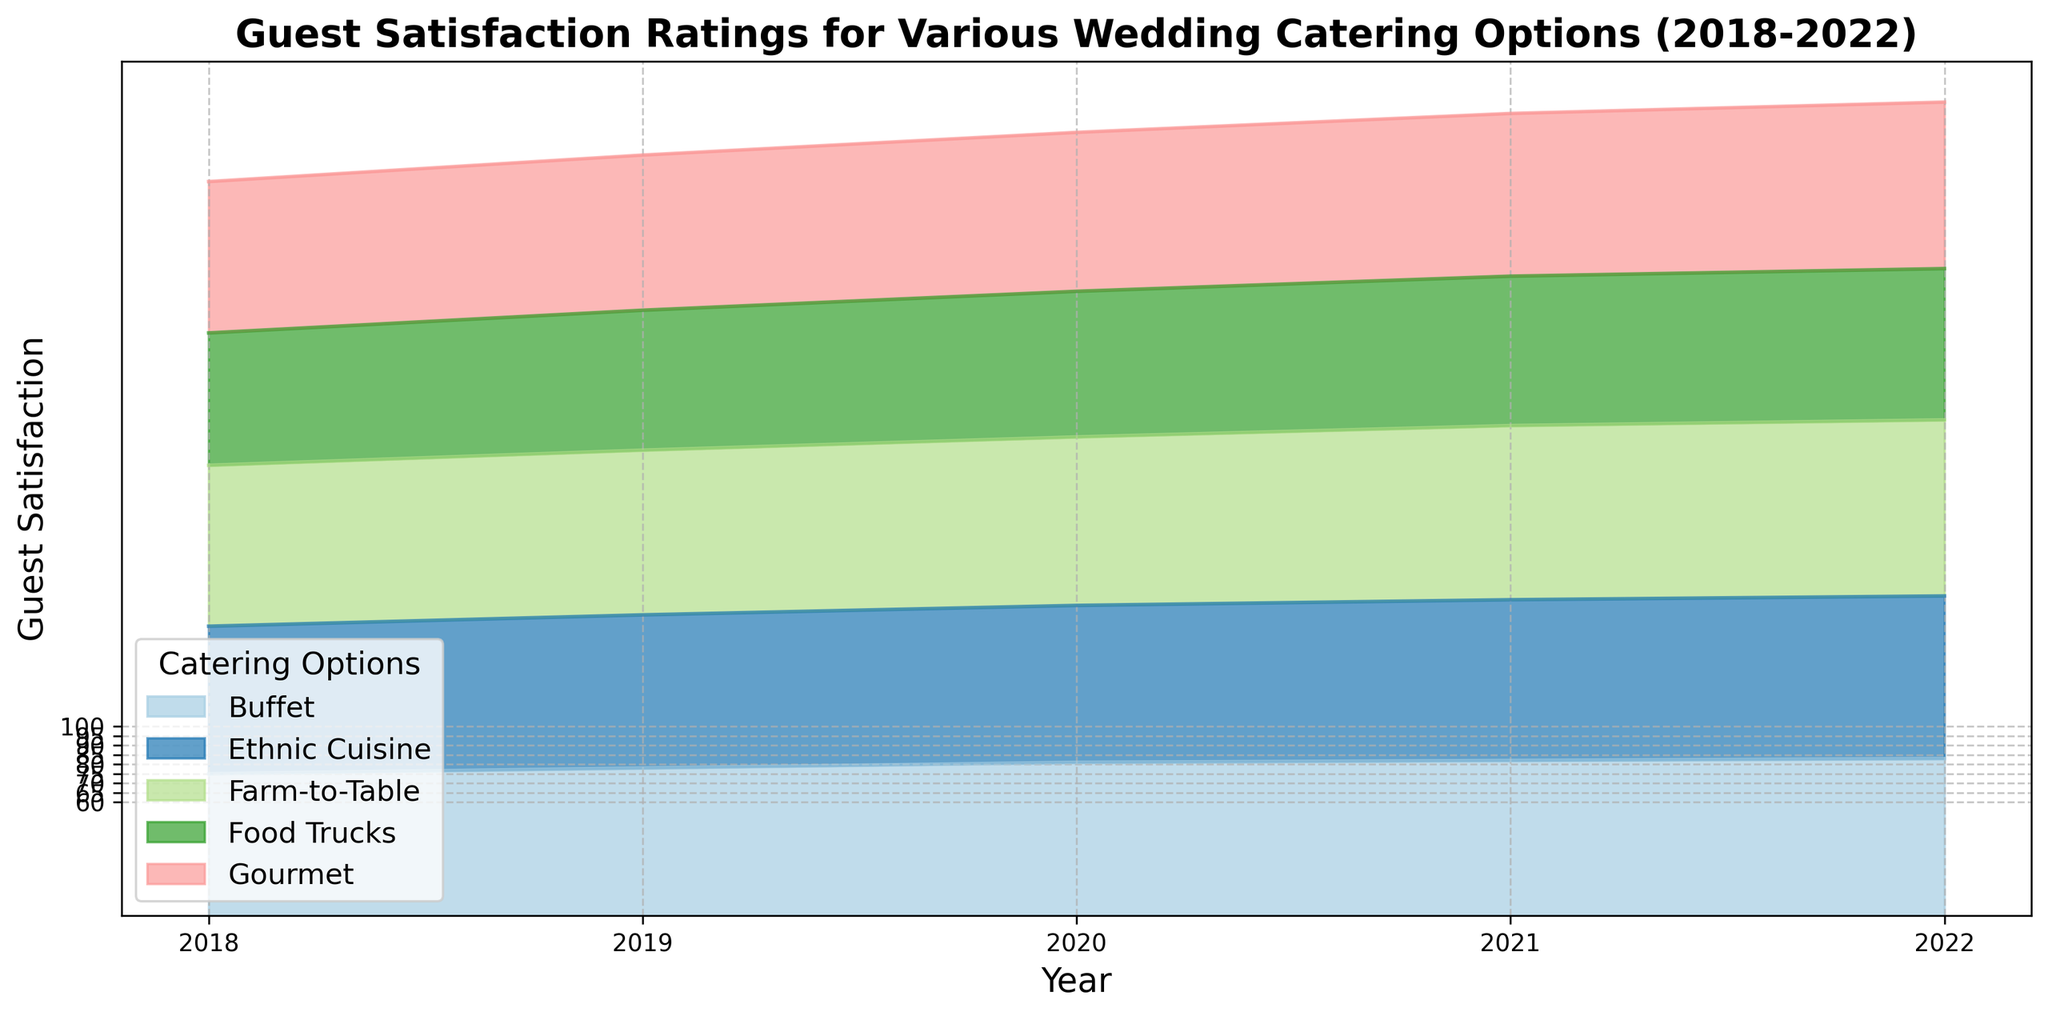What is the trend of the guest satisfaction rating for Farm-to-Table from 2018 to 2022? The guest satisfaction rating for Farm-to-Table rises year after year from 85 in 2018 to 93 in 2022, indicating a consistently increasing trend.
Answer: Increasing trend Which catering option had the highest guest satisfaction rating in 2022? In 2022, the catering option with the highest guest satisfaction rating is Farm-to-Table with a rating of 93.
Answer: Farm-to-Table Between Food Trucks and Buffet, which catering option saw a greater improvement in guest satisfaction from 2018 to 2022? The guest satisfaction rating for Food Trucks improved from 70 in 2018 to 80 in 2022 (increase of 10 points), while Buffet improved from 75 in 2018 to 83 in 2022 (increase of 8 points). Therefore, Food Trucks saw a greater improvement.
Answer: Food Trucks Compare the guest satisfaction ratings in 2019 between Gourmet and Ethnic Cuisine. Which one is higher? In 2019, Gourmet had a guest satisfaction rating of 82, while Ethnic Cuisine had a rating of 81. Therefore, Gourmet's rating is slightly higher.
Answer: Gourmet What is the difference in guest satisfaction ratings between the highest and lowest rated catering options in 2021? In 2021, the highest rating is Farm-to-Table with 92, and the lowest is Food Trucks with 79. The difference is 92 - 79 = 13.
Answer: 13 Calculate the average guest satisfaction rating for all catering options in 2020. Sum the ratings for 2020: Farm-to-Table (89) + Gourmet (84) + Buffet (81) + Food Trucks (77) + Ethnic Cuisine (83), then divide by 5. (89 + 84 + 81 + 77 + 83) / 5 = 414 / 5 = 82.8
Answer: 82.8 How does the guest satisfaction trend for Ethnic Cuisine from 2018 to 2022 compare with that for Gourmet? Both Ethnic Cuisine and Gourmet show an increasing trend from 2018 to 2022. Ethnic Cuisine rises from 78 to 86 and Gourmet rises from 80 to 88. Ethnic Cuisine generally starts lower and ends slightly lower but follows a similar growth pattern.
Answer: Similar growth Which two catering options had the closest guest satisfaction ratings in 2020? In 2020, Gourmet has a rating of 84 and Ethnic Cuisine has a rating of 83, making their ratings the closest to each other.
Answer: Gourmet and Ethnic Cuisine Based on the visual representation, which catering option consistently has the lowest guest satisfaction rating throughout the years 2018-2022? From 2018 to 2022, Food Trucks consistently have the lowest guest satisfaction rating compared to other options.
Answer: Food Trucks 